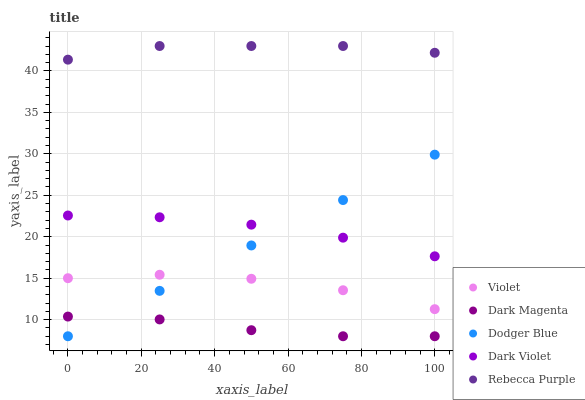Does Dark Magenta have the minimum area under the curve?
Answer yes or no. Yes. Does Rebecca Purple have the maximum area under the curve?
Answer yes or no. Yes. Does Dodger Blue have the minimum area under the curve?
Answer yes or no. No. Does Dodger Blue have the maximum area under the curve?
Answer yes or no. No. Is Dodger Blue the smoothest?
Answer yes or no. Yes. Is Violet the roughest?
Answer yes or no. Yes. Is Dark Magenta the smoothest?
Answer yes or no. No. Is Dark Magenta the roughest?
Answer yes or no. No. Does Dodger Blue have the lowest value?
Answer yes or no. Yes. Does Dark Violet have the lowest value?
Answer yes or no. No. Does Rebecca Purple have the highest value?
Answer yes or no. Yes. Does Dodger Blue have the highest value?
Answer yes or no. No. Is Dodger Blue less than Rebecca Purple?
Answer yes or no. Yes. Is Rebecca Purple greater than Dark Magenta?
Answer yes or no. Yes. Does Violet intersect Dodger Blue?
Answer yes or no. Yes. Is Violet less than Dodger Blue?
Answer yes or no. No. Is Violet greater than Dodger Blue?
Answer yes or no. No. Does Dodger Blue intersect Rebecca Purple?
Answer yes or no. No. 